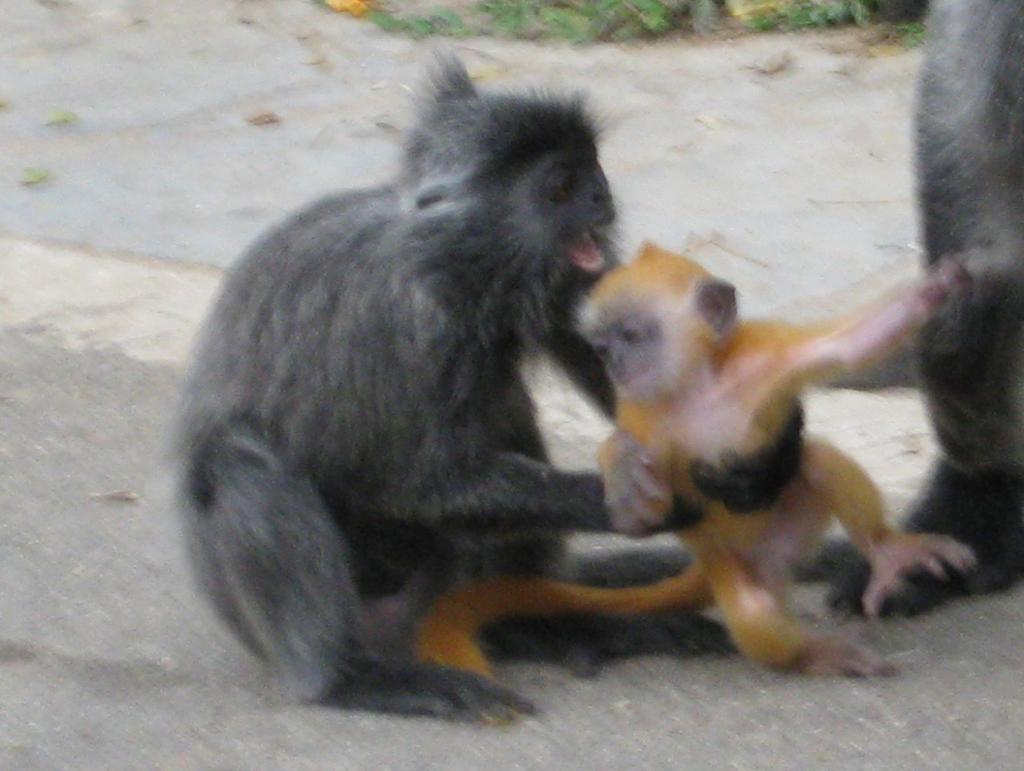Please provide a concise description of this image. In this image I can see few animals in brown and cream color. In the background I can see few plants in green color. 